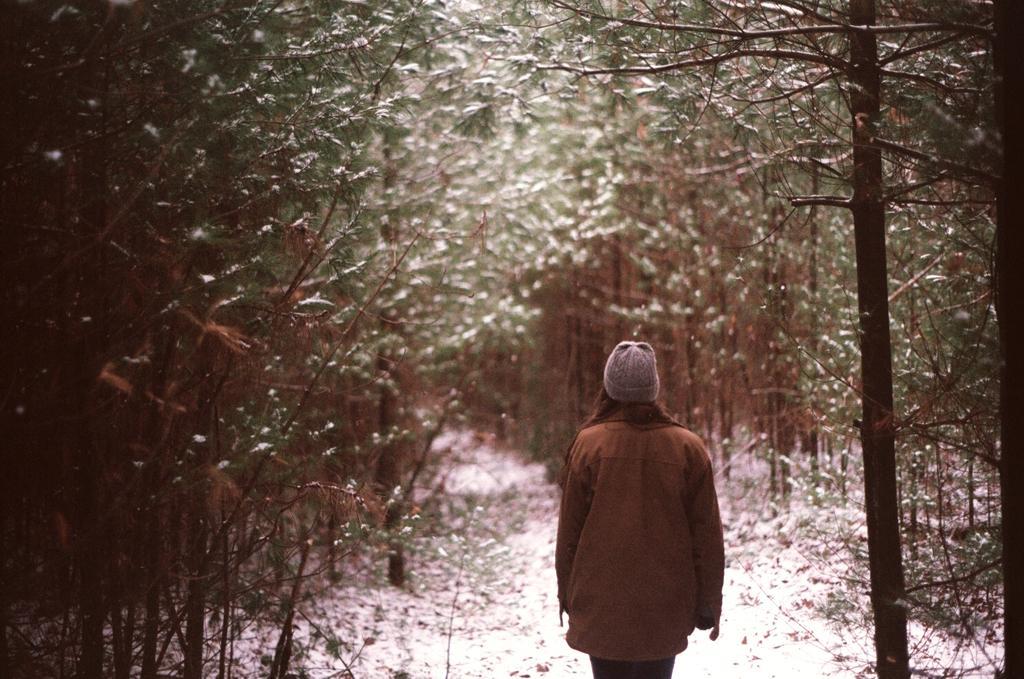Please provide a concise description of this image. In this picture there is a person with brown jacket is standing. At the back there are trees. At the bottom it looks like snow. 